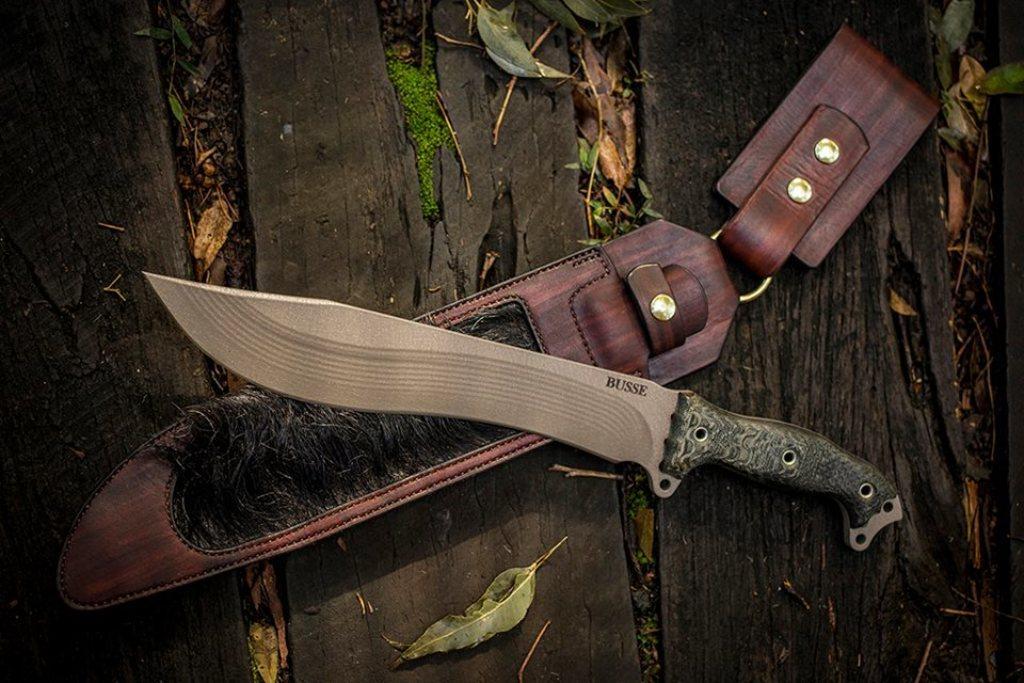Please provide a concise description of this image. In the center of the image we can see knife, knife holder are there. In the background of the image we can see wood and dry leaves are there. 